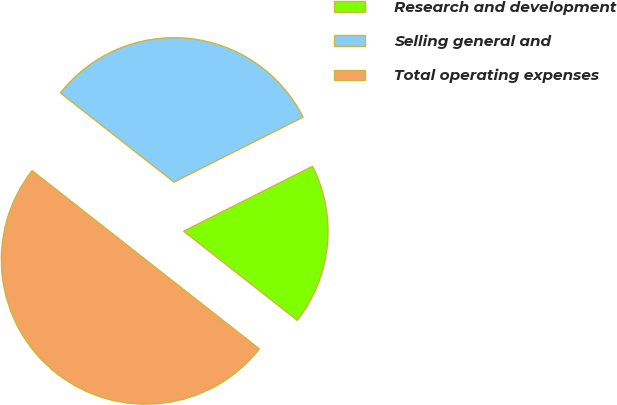Convert chart to OTSL. <chart><loc_0><loc_0><loc_500><loc_500><pie_chart><fcel>Research and development<fcel>Selling general and<fcel>Total operating expenses<nl><fcel>18.01%<fcel>31.99%<fcel>50.0%<nl></chart> 